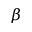<formula> <loc_0><loc_0><loc_500><loc_500>\beta</formula> 